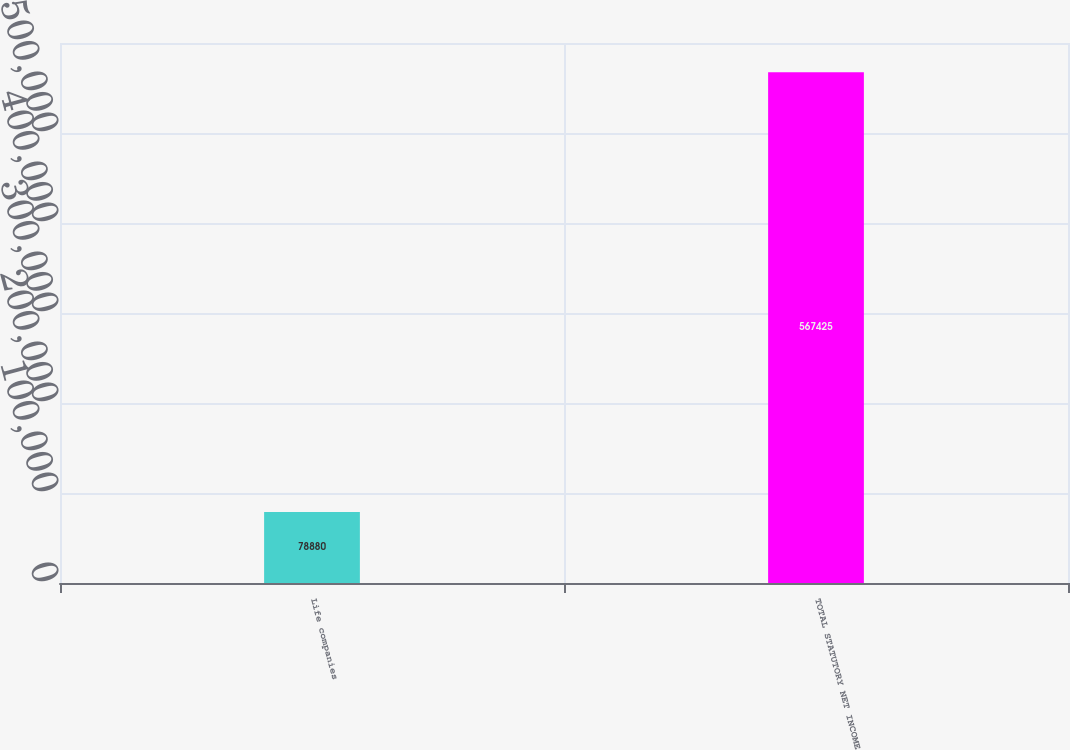Convert chart. <chart><loc_0><loc_0><loc_500><loc_500><bar_chart><fcel>Life companies<fcel>TOTAL STATUTORY NET INCOME<nl><fcel>78880<fcel>567425<nl></chart> 